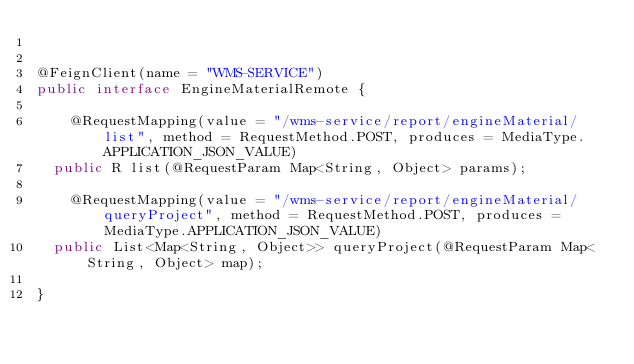Convert code to text. <code><loc_0><loc_0><loc_500><loc_500><_Java_>

@FeignClient(name = "WMS-SERVICE")
public interface EngineMaterialRemote {

    @RequestMapping(value = "/wms-service/report/engineMaterial/list", method = RequestMethod.POST, produces = MediaType.APPLICATION_JSON_VALUE)
	public R list(@RequestParam Map<String, Object> params);

    @RequestMapping(value = "/wms-service/report/engineMaterial/queryProject", method = RequestMethod.POST, produces = MediaType.APPLICATION_JSON_VALUE)
	public List<Map<String, Object>> queryProject(@RequestParam Map<String, Object> map);
 
}
</code> 